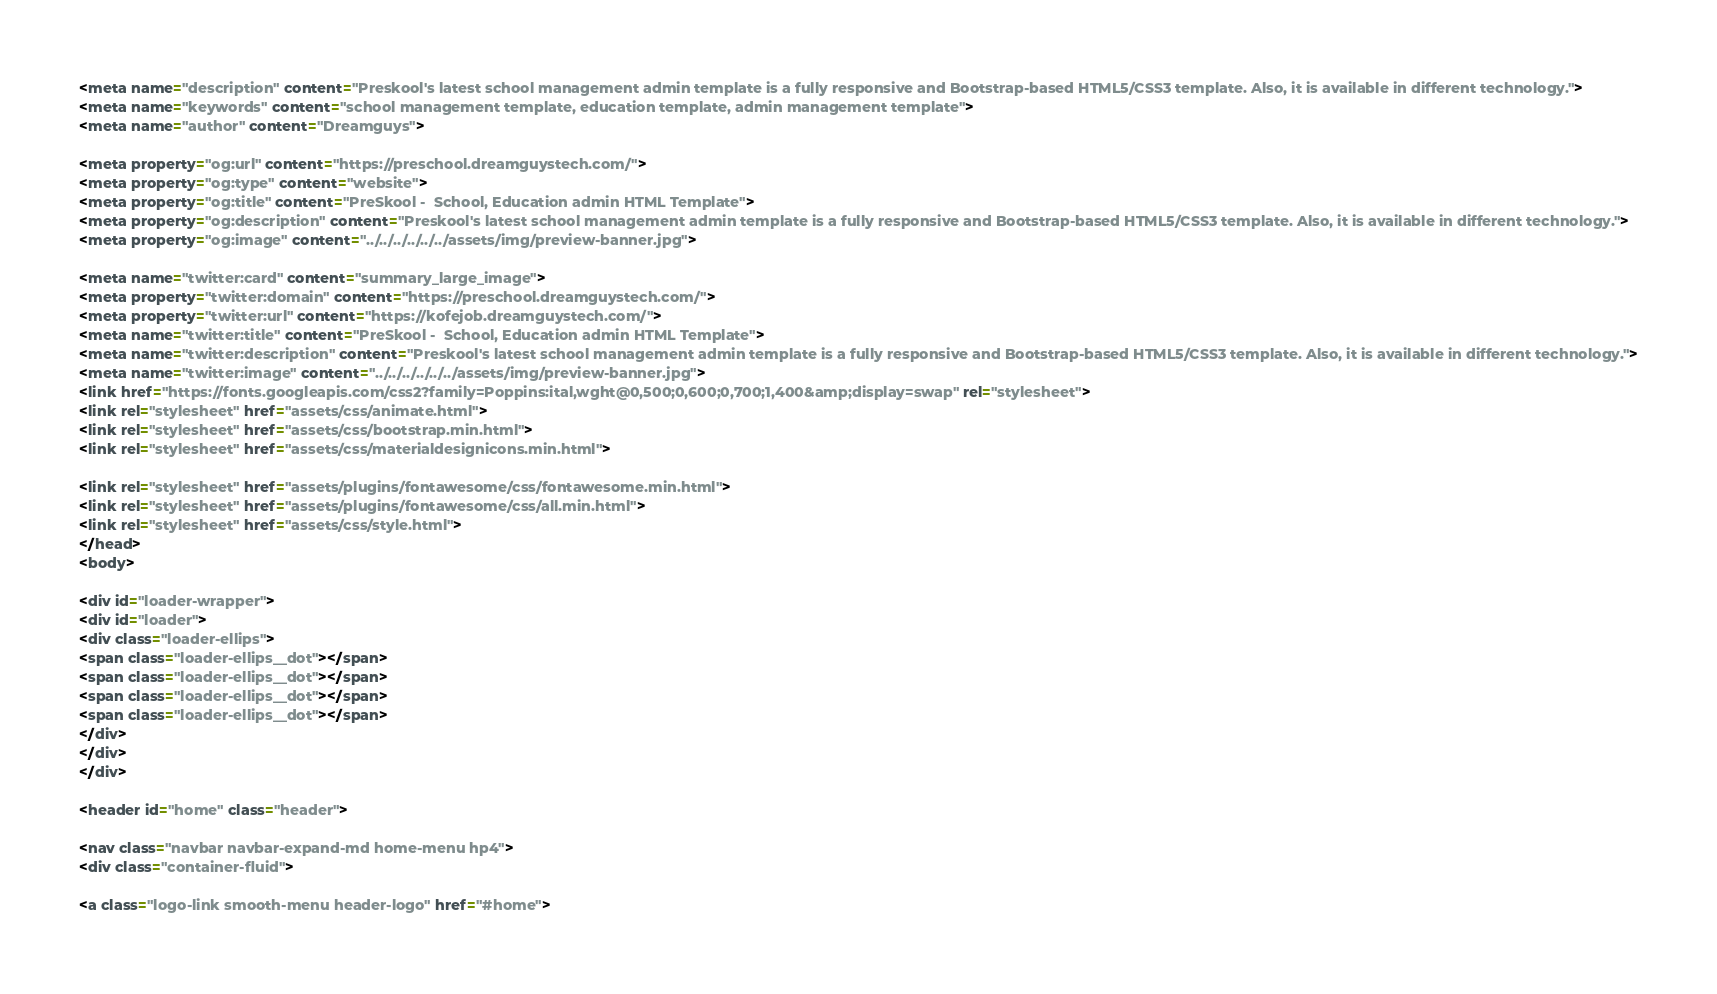<code> <loc_0><loc_0><loc_500><loc_500><_HTML_><meta name="description" content="Preskool's latest school management admin template is a fully responsive and Bootstrap-based HTML5/CSS3 template. Also, it is available in different technology.">
<meta name="keywords" content="school management template, education template, admin management template">
<meta name="author" content="Dreamguys">

<meta property="og:url" content="https://preschool.dreamguystech.com/">
<meta property="og:type" content="website">
<meta property="og:title" content="PreSkool -  School, Education admin HTML Template">
<meta property="og:description" content="Preskool's latest school management admin template is a fully responsive and Bootstrap-based HTML5/CSS3 template. Also, it is available in different technology.">
<meta property="og:image" content="../../../../../../assets/img/preview-banner.jpg">

<meta name="twitter:card" content="summary_large_image">
<meta property="twitter:domain" content="https://preschool.dreamguystech.com/">
<meta property="twitter:url" content="https://kofejob.dreamguystech.com/">
<meta name="twitter:title" content="PreSkool -  School, Education admin HTML Template">
<meta name="twitter:description" content="Preskool's latest school management admin template is a fully responsive and Bootstrap-based HTML5/CSS3 template. Also, it is available in different technology.">
<meta name="twitter:image" content="../../../../../../assets/img/preview-banner.jpg">
<link href="https://fonts.googleapis.com/css2?family=Poppins:ital,wght@0,500;0,600;0,700;1,400&amp;display=swap" rel="stylesheet">
<link rel="stylesheet" href="assets/css/animate.html">
<link rel="stylesheet" href="assets/css/bootstrap.min.html">
<link rel="stylesheet" href="assets/css/materialdesignicons.min.html">

<link rel="stylesheet" href="assets/plugins/fontawesome/css/fontawesome.min.html">
<link rel="stylesheet" href="assets/plugins/fontawesome/css/all.min.html">
<link rel="stylesheet" href="assets/css/style.html">
</head>
<body>

<div id="loader-wrapper">
<div id="loader">
<div class="loader-ellips">
<span class="loader-ellips__dot"></span>
<span class="loader-ellips__dot"></span>
<span class="loader-ellips__dot"></span>
<span class="loader-ellips__dot"></span>
</div>
</div>
</div>

<header id="home" class="header">

<nav class="navbar navbar-expand-md home-menu hp4">
<div class="container-fluid">

<a class="logo-link smooth-menu header-logo" href="#home"></code> 